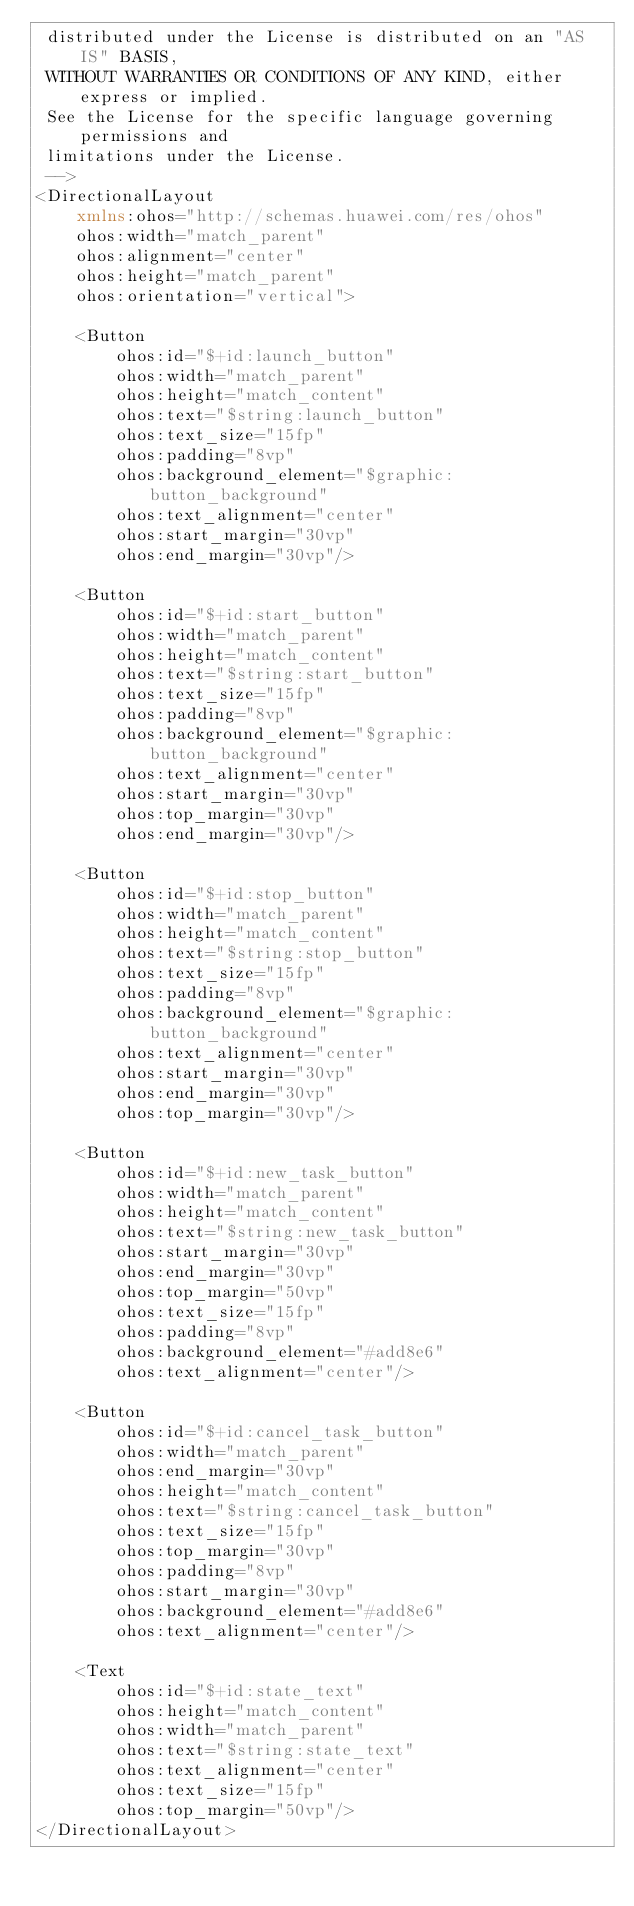<code> <loc_0><loc_0><loc_500><loc_500><_XML_> distributed under the License is distributed on an "AS IS" BASIS,
 WITHOUT WARRANTIES OR CONDITIONS OF ANY KIND, either express or implied.
 See the License for the specific language governing permissions and
 limitations under the License.
 -->
<DirectionalLayout
    xmlns:ohos="http://schemas.huawei.com/res/ohos"
    ohos:width="match_parent"
    ohos:alignment="center"
    ohos:height="match_parent"
    ohos:orientation="vertical">

    <Button
        ohos:id="$+id:launch_button"
        ohos:width="match_parent"
        ohos:height="match_content"
        ohos:text="$string:launch_button"
        ohos:text_size="15fp"
        ohos:padding="8vp"
        ohos:background_element="$graphic:button_background"
        ohos:text_alignment="center"
        ohos:start_margin="30vp"
        ohos:end_margin="30vp"/>

    <Button
        ohos:id="$+id:start_button"
        ohos:width="match_parent"
        ohos:height="match_content"
        ohos:text="$string:start_button"
        ohos:text_size="15fp"
        ohos:padding="8vp"
        ohos:background_element="$graphic:button_background"
        ohos:text_alignment="center"
        ohos:start_margin="30vp"
        ohos:top_margin="30vp"
        ohos:end_margin="30vp"/>

    <Button
        ohos:id="$+id:stop_button"
        ohos:width="match_parent"
        ohos:height="match_content"
        ohos:text="$string:stop_button"
        ohos:text_size="15fp"
        ohos:padding="8vp"
        ohos:background_element="$graphic:button_background"
        ohos:text_alignment="center"
        ohos:start_margin="30vp"
        ohos:end_margin="30vp"
        ohos:top_margin="30vp"/>

    <Button
        ohos:id="$+id:new_task_button"
        ohos:width="match_parent"
        ohos:height="match_content"
        ohos:text="$string:new_task_button"
        ohos:start_margin="30vp"
        ohos:end_margin="30vp"
        ohos:top_margin="50vp"
        ohos:text_size="15fp"
        ohos:padding="8vp"
        ohos:background_element="#add8e6"
        ohos:text_alignment="center"/>

    <Button
        ohos:id="$+id:cancel_task_button"
        ohos:width="match_parent"
        ohos:end_margin="30vp"
        ohos:height="match_content"
        ohos:text="$string:cancel_task_button"
        ohos:text_size="15fp"
        ohos:top_margin="30vp"
        ohos:padding="8vp"
        ohos:start_margin="30vp"
        ohos:background_element="#add8e6"
        ohos:text_alignment="center"/>

    <Text
        ohos:id="$+id:state_text"
        ohos:height="match_content"
        ohos:width="match_parent"
        ohos:text="$string:state_text"
        ohos:text_alignment="center"
        ohos:text_size="15fp"
        ohos:top_margin="50vp"/>
</DirectionalLayout></code> 